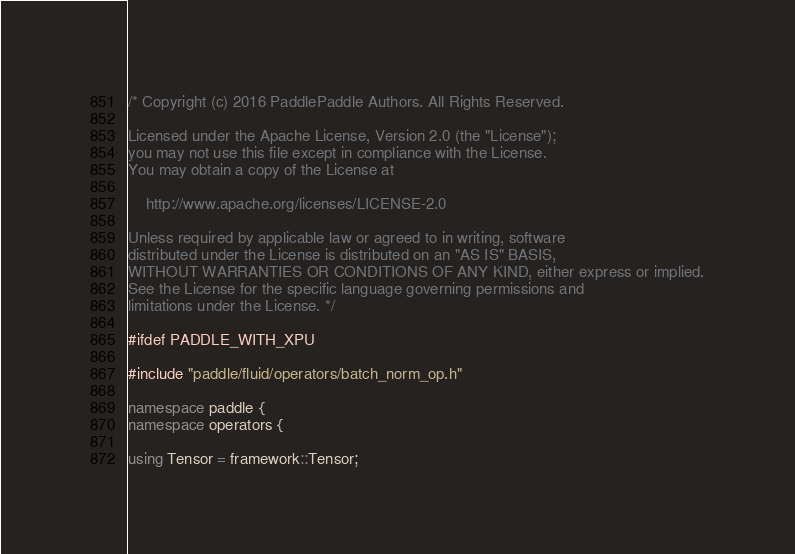Convert code to text. <code><loc_0><loc_0><loc_500><loc_500><_C++_>/* Copyright (c) 2016 PaddlePaddle Authors. All Rights Reserved.

Licensed under the Apache License, Version 2.0 (the "License");
you may not use this file except in compliance with the License.
You may obtain a copy of the License at

    http://www.apache.org/licenses/LICENSE-2.0

Unless required by applicable law or agreed to in writing, software
distributed under the License is distributed on an "AS IS" BASIS,
WITHOUT WARRANTIES OR CONDITIONS OF ANY KIND, either express or implied.
See the License for the specific language governing permissions and
limitations under the License. */

#ifdef PADDLE_WITH_XPU

#include "paddle/fluid/operators/batch_norm_op.h"

namespace paddle {
namespace operators {

using Tensor = framework::Tensor;</code> 